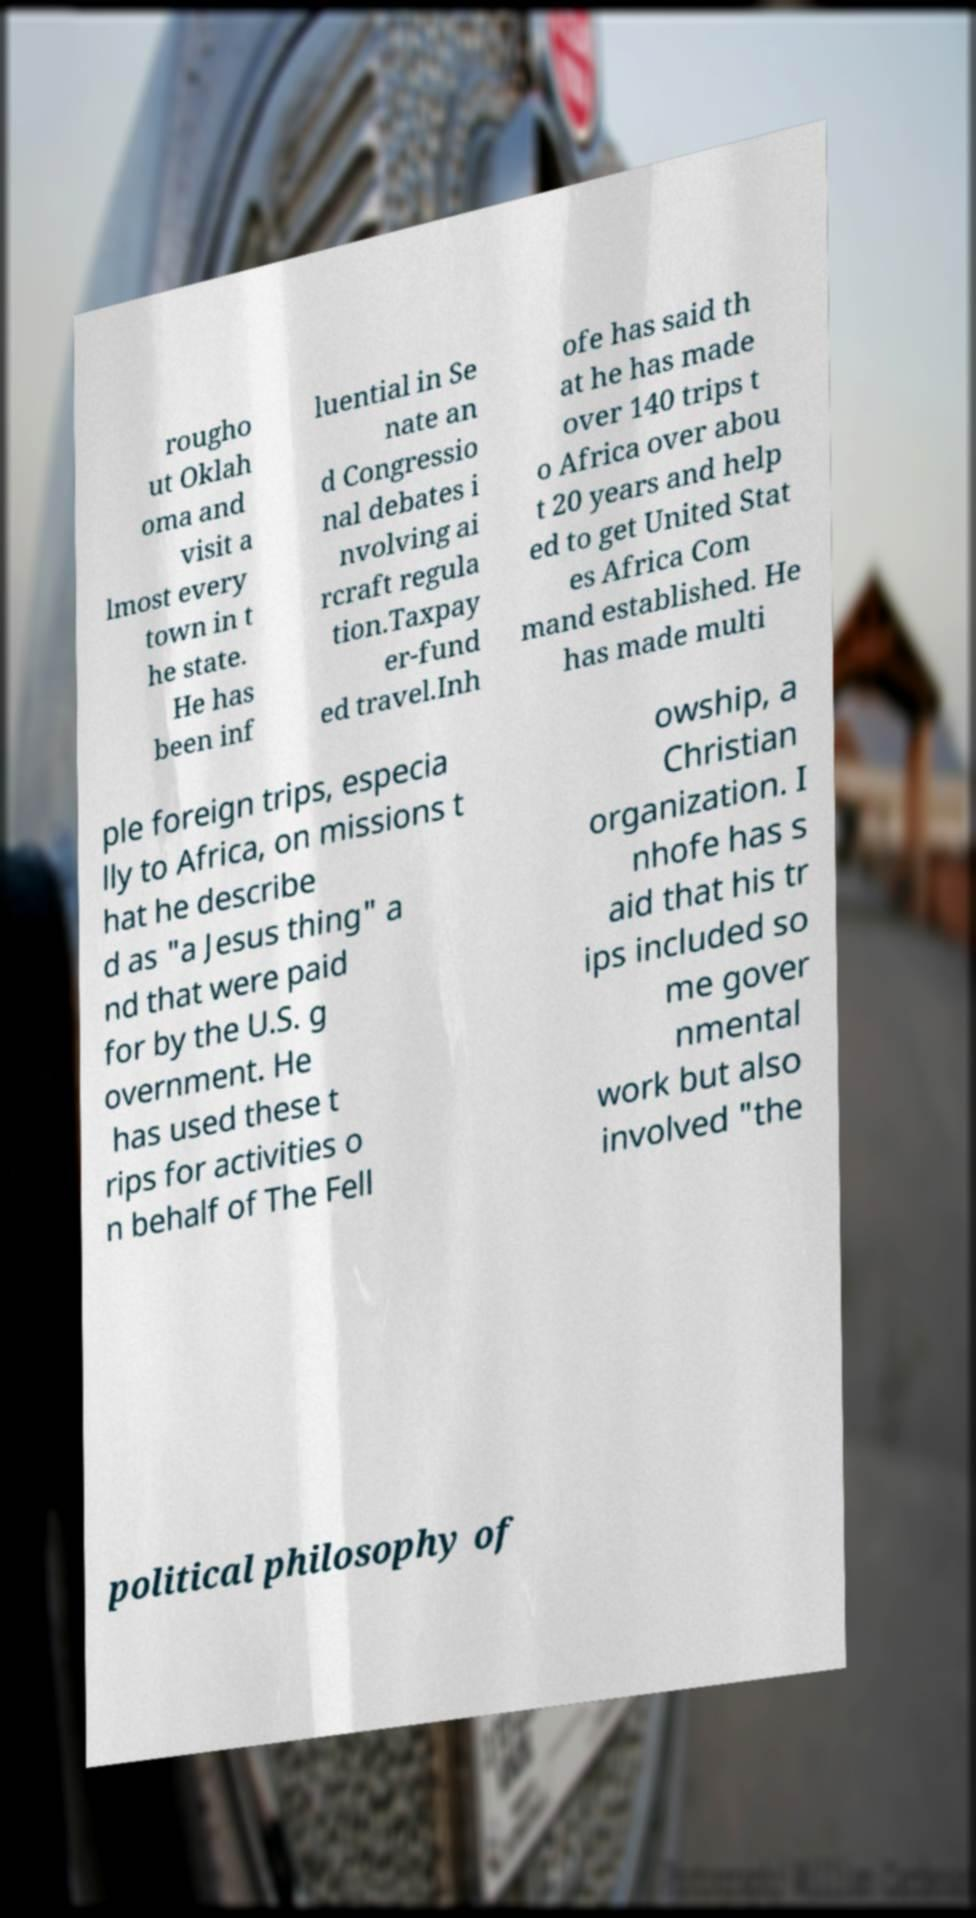Could you extract and type out the text from this image? rougho ut Oklah oma and visit a lmost every town in t he state. He has been inf luential in Se nate an d Congressio nal debates i nvolving ai rcraft regula tion.Taxpay er-fund ed travel.Inh ofe has said th at he has made over 140 trips t o Africa over abou t 20 years and help ed to get United Stat es Africa Com mand established. He has made multi ple foreign trips, especia lly to Africa, on missions t hat he describe d as "a Jesus thing" a nd that were paid for by the U.S. g overnment. He has used these t rips for activities o n behalf of The Fell owship, a Christian organization. I nhofe has s aid that his tr ips included so me gover nmental work but also involved "the political philosophy of 